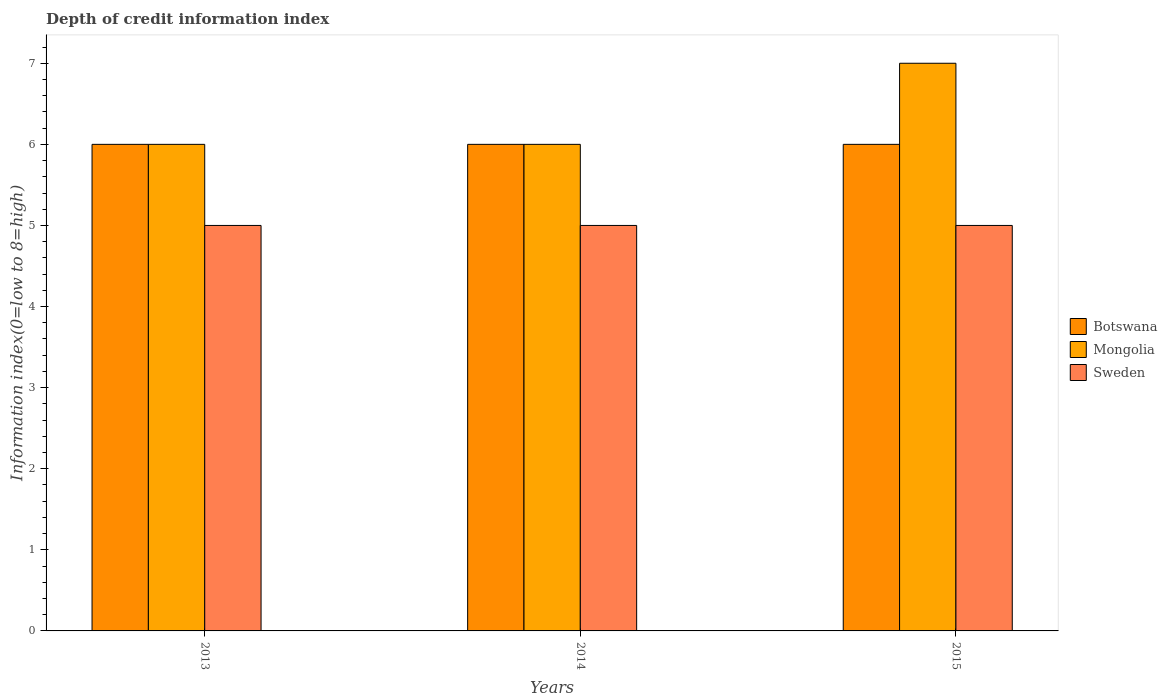How many different coloured bars are there?
Offer a very short reply. 3. Are the number of bars on each tick of the X-axis equal?
Offer a very short reply. Yes. How many bars are there on the 2nd tick from the right?
Your answer should be compact. 3. What is the label of the 3rd group of bars from the left?
Provide a short and direct response. 2015. In how many cases, is the number of bars for a given year not equal to the number of legend labels?
Offer a terse response. 0. Across all years, what is the maximum information index in Botswana?
Provide a succinct answer. 6. Across all years, what is the minimum information index in Botswana?
Offer a terse response. 6. In which year was the information index in Sweden minimum?
Offer a terse response. 2013. What is the total information index in Botswana in the graph?
Your answer should be compact. 18. What is the difference between the information index in Mongolia in 2014 and that in 2015?
Your response must be concise. -1. What is the difference between the information index in Sweden in 2015 and the information index in Botswana in 2014?
Your answer should be very brief. -1. In the year 2014, what is the difference between the information index in Botswana and information index in Sweden?
Ensure brevity in your answer.  1. In how many years, is the information index in Mongolia greater than 4.2?
Your answer should be compact. 3. What is the difference between the highest and the lowest information index in Sweden?
Your response must be concise. 0. In how many years, is the information index in Botswana greater than the average information index in Botswana taken over all years?
Ensure brevity in your answer.  0. Is the sum of the information index in Mongolia in 2014 and 2015 greater than the maximum information index in Botswana across all years?
Provide a succinct answer. Yes. What does the 1st bar from the left in 2013 represents?
Ensure brevity in your answer.  Botswana. What does the 3rd bar from the right in 2014 represents?
Your answer should be compact. Botswana. Is it the case that in every year, the sum of the information index in Sweden and information index in Botswana is greater than the information index in Mongolia?
Offer a very short reply. Yes. Are all the bars in the graph horizontal?
Offer a very short reply. No. What is the difference between two consecutive major ticks on the Y-axis?
Offer a terse response. 1. Does the graph contain grids?
Provide a short and direct response. No. Where does the legend appear in the graph?
Keep it short and to the point. Center right. How are the legend labels stacked?
Give a very brief answer. Vertical. What is the title of the graph?
Provide a succinct answer. Depth of credit information index. What is the label or title of the Y-axis?
Give a very brief answer. Information index(0=low to 8=high). What is the Information index(0=low to 8=high) of Mongolia in 2013?
Your answer should be compact. 6. What is the Information index(0=low to 8=high) in Mongolia in 2014?
Ensure brevity in your answer.  6. What is the Information index(0=low to 8=high) in Sweden in 2014?
Provide a succinct answer. 5. What is the Information index(0=low to 8=high) in Botswana in 2015?
Provide a short and direct response. 6. What is the Information index(0=low to 8=high) of Sweden in 2015?
Make the answer very short. 5. Across all years, what is the minimum Information index(0=low to 8=high) of Mongolia?
Ensure brevity in your answer.  6. Across all years, what is the minimum Information index(0=low to 8=high) of Sweden?
Keep it short and to the point. 5. What is the total Information index(0=low to 8=high) in Botswana in the graph?
Ensure brevity in your answer.  18. What is the total Information index(0=low to 8=high) of Sweden in the graph?
Your answer should be very brief. 15. What is the difference between the Information index(0=low to 8=high) of Mongolia in 2013 and that in 2014?
Your answer should be very brief. 0. What is the difference between the Information index(0=low to 8=high) of Sweden in 2013 and that in 2014?
Provide a succinct answer. 0. What is the difference between the Information index(0=low to 8=high) in Mongolia in 2013 and that in 2015?
Offer a terse response. -1. What is the difference between the Information index(0=low to 8=high) of Botswana in 2014 and that in 2015?
Provide a succinct answer. 0. What is the difference between the Information index(0=low to 8=high) in Mongolia in 2014 and that in 2015?
Give a very brief answer. -1. What is the difference between the Information index(0=low to 8=high) of Botswana in 2013 and the Information index(0=low to 8=high) of Sweden in 2014?
Make the answer very short. 1. What is the difference between the Information index(0=low to 8=high) of Mongolia in 2013 and the Information index(0=low to 8=high) of Sweden in 2014?
Keep it short and to the point. 1. What is the difference between the Information index(0=low to 8=high) of Botswana in 2013 and the Information index(0=low to 8=high) of Mongolia in 2015?
Keep it short and to the point. -1. What is the difference between the Information index(0=low to 8=high) in Botswana in 2014 and the Information index(0=low to 8=high) in Mongolia in 2015?
Your answer should be compact. -1. What is the difference between the Information index(0=low to 8=high) of Botswana in 2014 and the Information index(0=low to 8=high) of Sweden in 2015?
Your answer should be very brief. 1. What is the average Information index(0=low to 8=high) in Botswana per year?
Offer a terse response. 6. What is the average Information index(0=low to 8=high) of Mongolia per year?
Offer a terse response. 6.33. In the year 2013, what is the difference between the Information index(0=low to 8=high) of Botswana and Information index(0=low to 8=high) of Mongolia?
Make the answer very short. 0. In the year 2013, what is the difference between the Information index(0=low to 8=high) of Mongolia and Information index(0=low to 8=high) of Sweden?
Keep it short and to the point. 1. In the year 2014, what is the difference between the Information index(0=low to 8=high) in Botswana and Information index(0=low to 8=high) in Mongolia?
Give a very brief answer. 0. In the year 2014, what is the difference between the Information index(0=low to 8=high) of Botswana and Information index(0=low to 8=high) of Sweden?
Make the answer very short. 1. In the year 2014, what is the difference between the Information index(0=low to 8=high) in Mongolia and Information index(0=low to 8=high) in Sweden?
Your answer should be compact. 1. In the year 2015, what is the difference between the Information index(0=low to 8=high) in Botswana and Information index(0=low to 8=high) in Sweden?
Ensure brevity in your answer.  1. In the year 2015, what is the difference between the Information index(0=low to 8=high) of Mongolia and Information index(0=low to 8=high) of Sweden?
Offer a terse response. 2. What is the ratio of the Information index(0=low to 8=high) of Mongolia in 2013 to that in 2014?
Offer a very short reply. 1. What is the ratio of the Information index(0=low to 8=high) of Sweden in 2013 to that in 2014?
Make the answer very short. 1. What is the ratio of the Information index(0=low to 8=high) in Botswana in 2013 to that in 2015?
Keep it short and to the point. 1. What is the ratio of the Information index(0=low to 8=high) of Sweden in 2013 to that in 2015?
Your answer should be compact. 1. What is the ratio of the Information index(0=low to 8=high) of Botswana in 2014 to that in 2015?
Your answer should be compact. 1. What is the ratio of the Information index(0=low to 8=high) in Sweden in 2014 to that in 2015?
Make the answer very short. 1. What is the difference between the highest and the second highest Information index(0=low to 8=high) of Mongolia?
Provide a succinct answer. 1. What is the difference between the highest and the lowest Information index(0=low to 8=high) in Mongolia?
Offer a terse response. 1. 